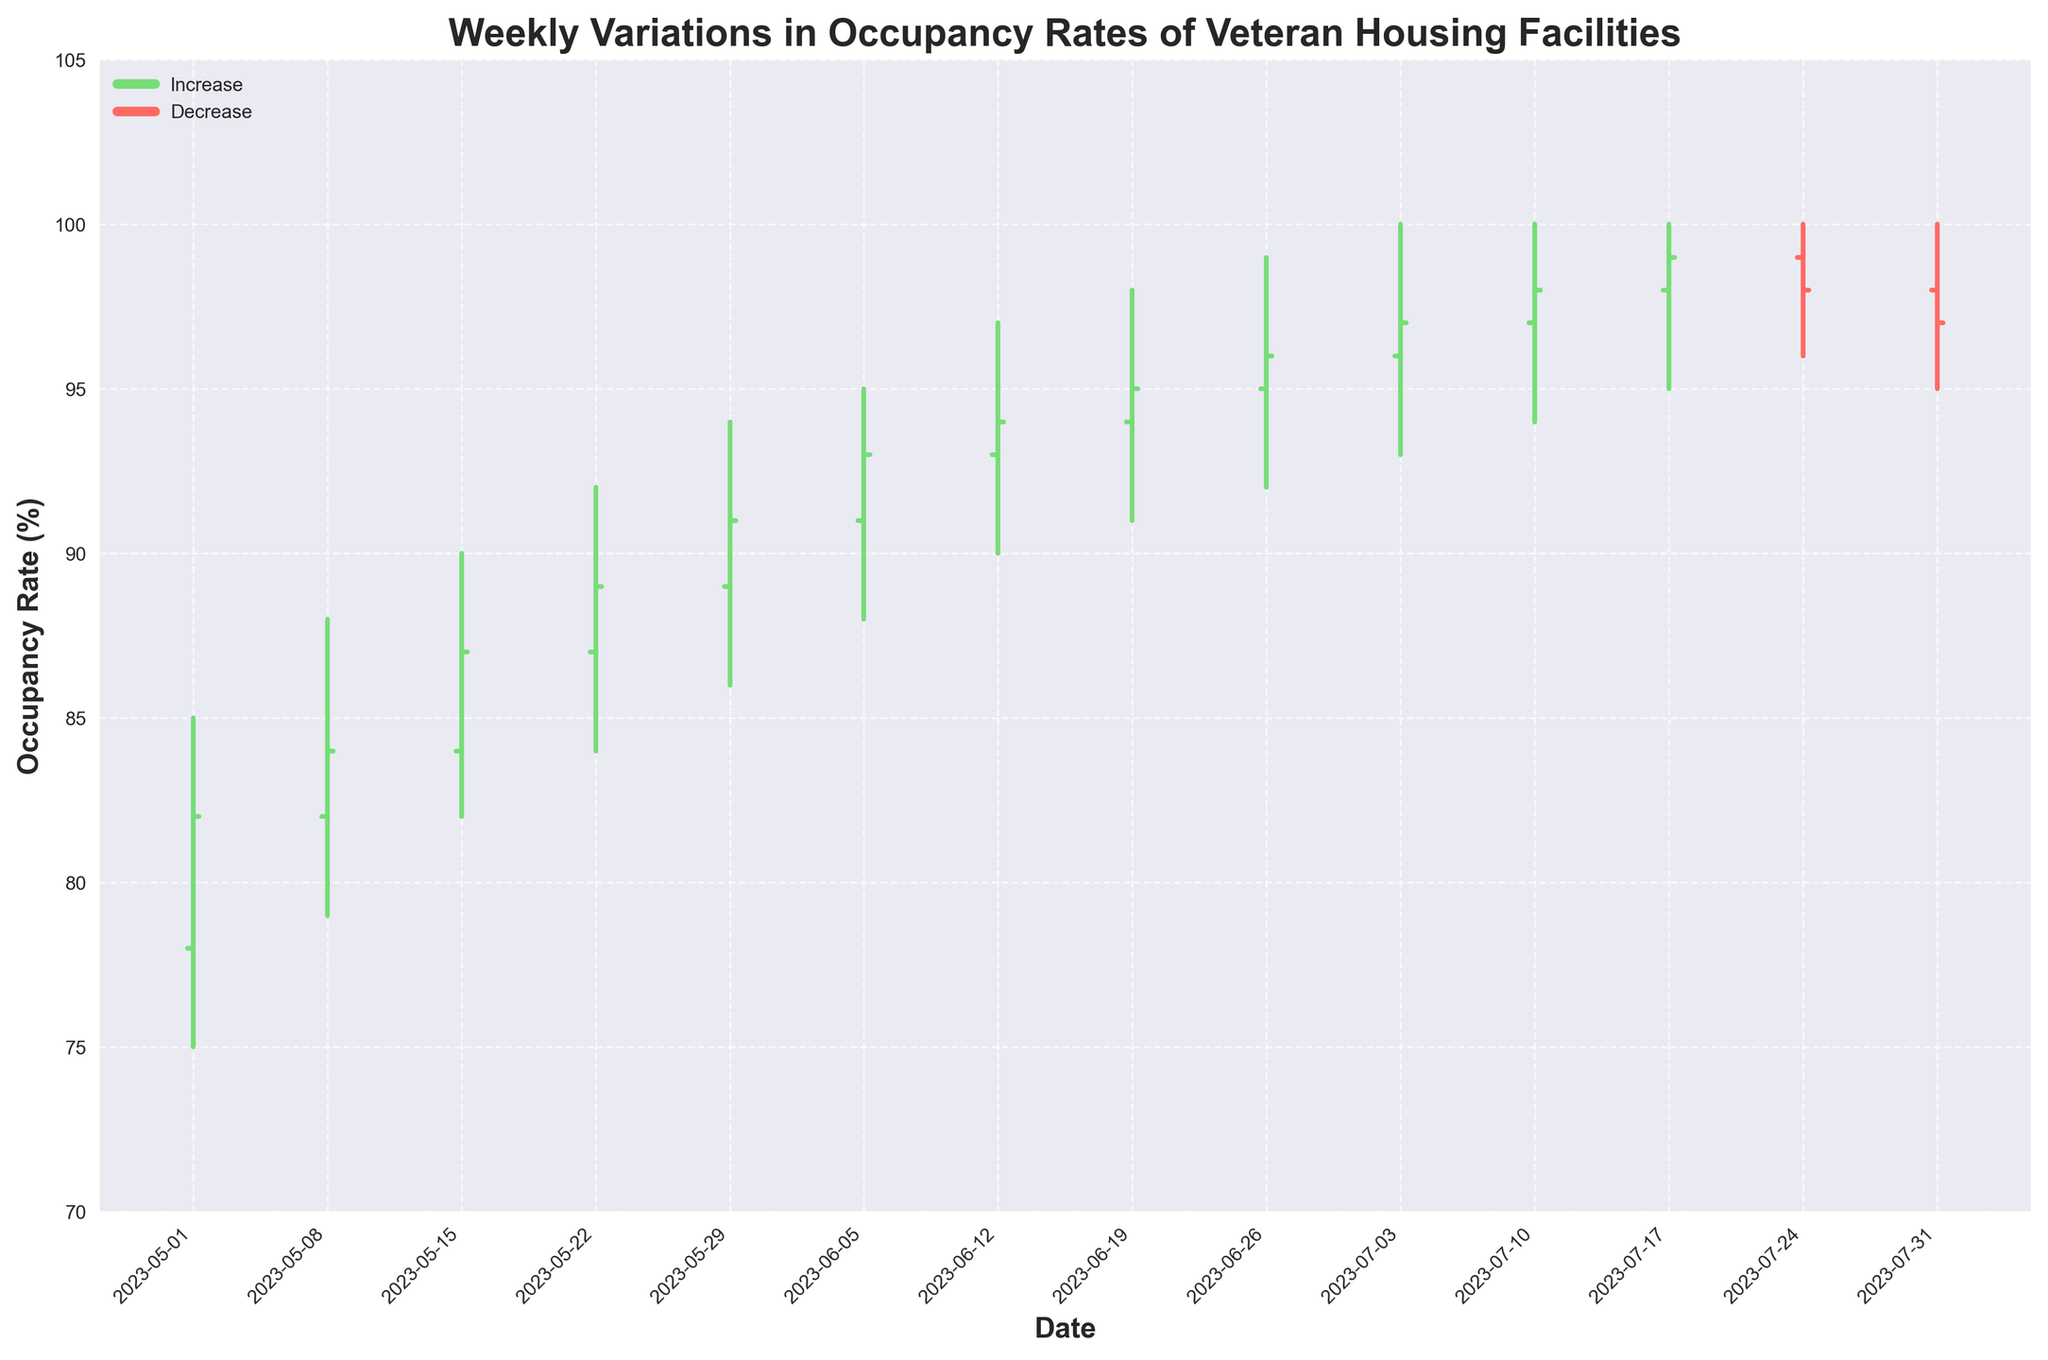What does the title of the figure indicate? The title of the figure is "Weekly Variations in Occupancy Rates of Veteran Housing Facilities." It indicates that the chart shows how the occupancy rates of veteran housing facilities have changed on a weekly basis.
Answer: Weekly Variations in Occupancy Rates of Veteran Housing Facilities Which color represents an increase in occupancy rates? The legend at the upper left explains the colors. The green color represents an increase in occupancy rates.
Answer: Green How many weeks show a decrease in occupancy rates? By looking at the red lines (indicating decreases) in the figure, we count six weeks where the occupancy rates decreased. Specifically, weeks with end dates: 2023-07-31, 2023-07-24, 2023-07-17, 2023-07-10, 2023-07-03, and 2023-05-31.
Answer: Six weeks What was the highest occupancy rate recorded during the period shown? The highest value in the High column should be identified. Here, a high of 100 was recorded between weeks ending on 2023-07-24 and 2023-07-31.
Answer: 100% What was the lowest close rate reported over the plotted weeks? By examining the Close values on the chart, the lowest closing rate was 82, which occurred in the week ending 2023-05-01.
Answer: 82% What are the occupancy rates at the start and end of the observation period? The Open value of the first week (2023-05-01) is 78, and the Close value of the last week (2023-07-31) is 97. Comparing these values, 78 at the start and 97 at the end.
Answer: 78% and 97% How many weeks experienced both their high and low rates within the range of 90-100%? Identify the weeks where both high and low values fall within the 90-100% range. There are six such weeks: 2023-06-19, 2023-06-26, 2023-07-03, 2023-07-10, 2023-07-17, and 2023-07-24.
Answer: Six weeks What's the average closing rate from May 1, 2023, to July 31, 2023? Add up all the closing rates (82, 84, 87, 89, 91, 93, 94, 95, 96, 97, 98, 99, 98, 97) and divide by the number of weeks (14). Sum = 1308, Average = 1308/14 = 93.43%.
Answer: 93.43% When comparing the opening rate of the week ending on May 1, 2023, to the closing rate of the week ending on July 31, 2023, how much did occupancy rates increase by percentage points? The opening rate for May 1, 2023, was 78%, and the closing rate for July 31, 2023, was 97%. Thus, the increase is 97 - 78 = 19 percentage points.
Answer: 19 percentage points 